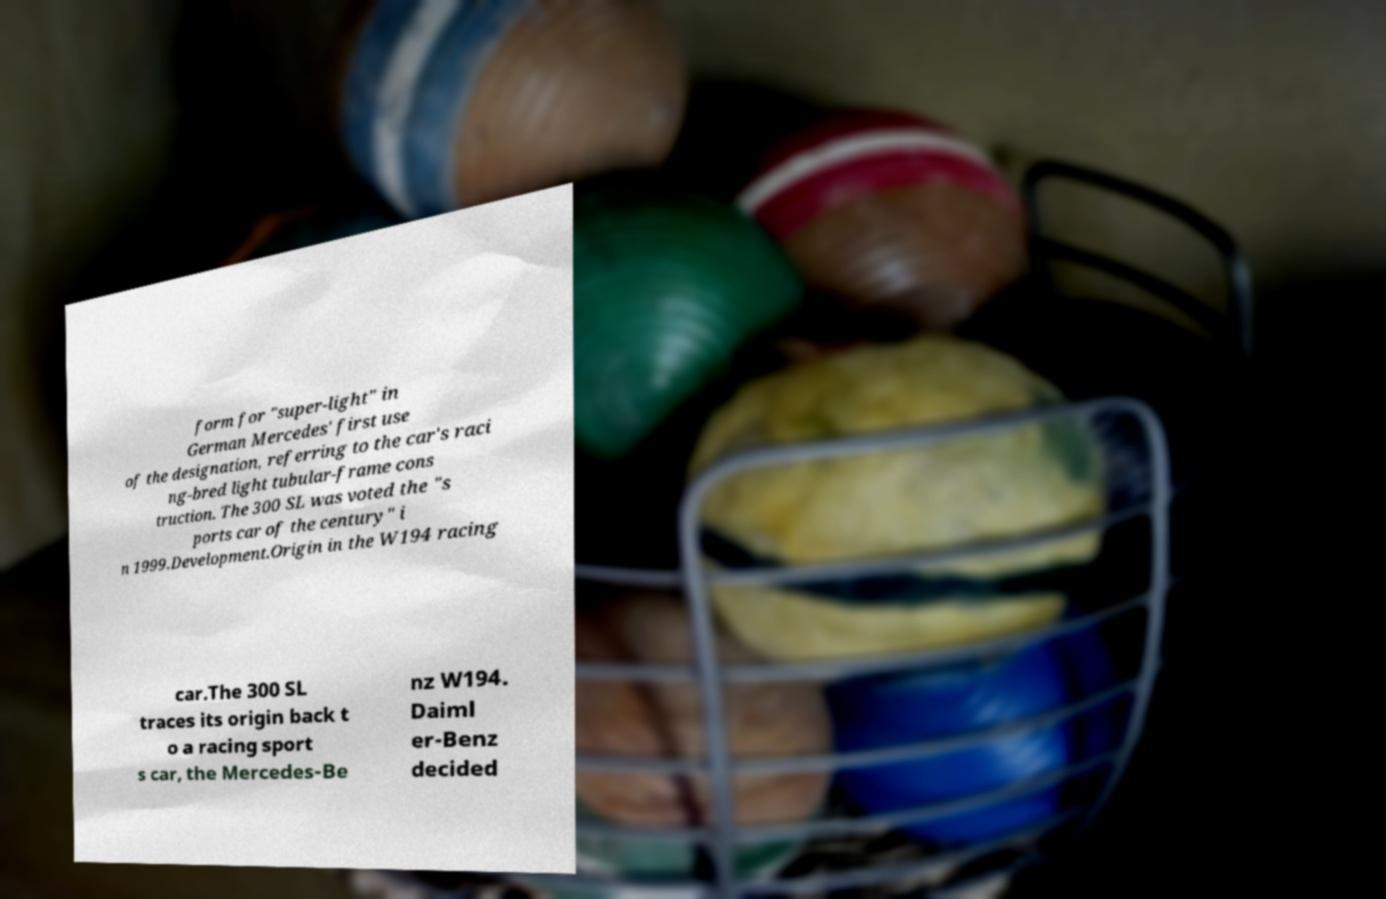Please identify and transcribe the text found in this image. form for "super-light" in German Mercedes' first use of the designation, referring to the car's raci ng-bred light tubular-frame cons truction. The 300 SL was voted the "s ports car of the century" i n 1999.Development.Origin in the W194 racing car.The 300 SL traces its origin back t o a racing sport s car, the Mercedes-Be nz W194. Daiml er-Benz decided 